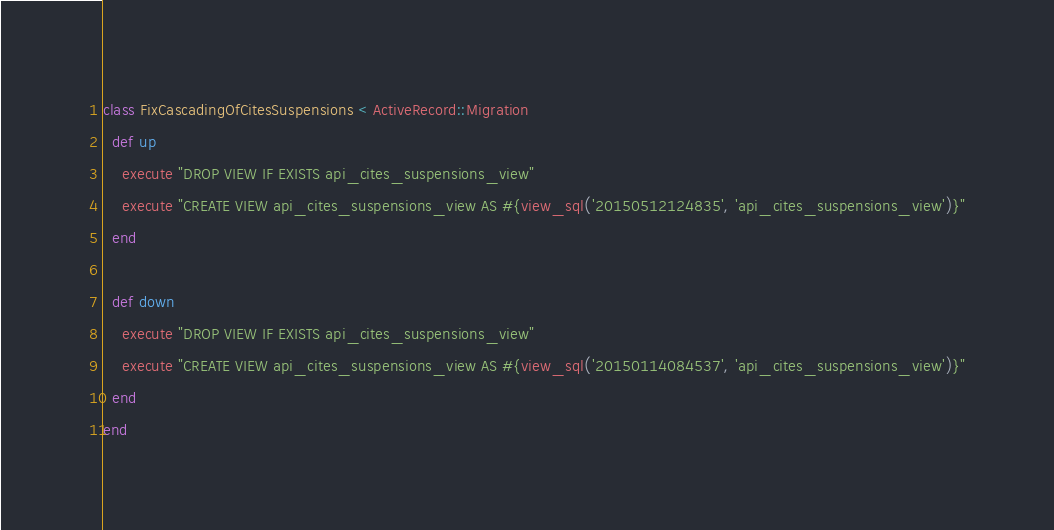<code> <loc_0><loc_0><loc_500><loc_500><_Ruby_>class FixCascadingOfCitesSuspensions < ActiveRecord::Migration
  def up
    execute "DROP VIEW IF EXISTS api_cites_suspensions_view"
    execute "CREATE VIEW api_cites_suspensions_view AS #{view_sql('20150512124835', 'api_cites_suspensions_view')}"
  end

  def down
    execute "DROP VIEW IF EXISTS api_cites_suspensions_view"
    execute "CREATE VIEW api_cites_suspensions_view AS #{view_sql('20150114084537', 'api_cites_suspensions_view')}"
  end
end
</code> 